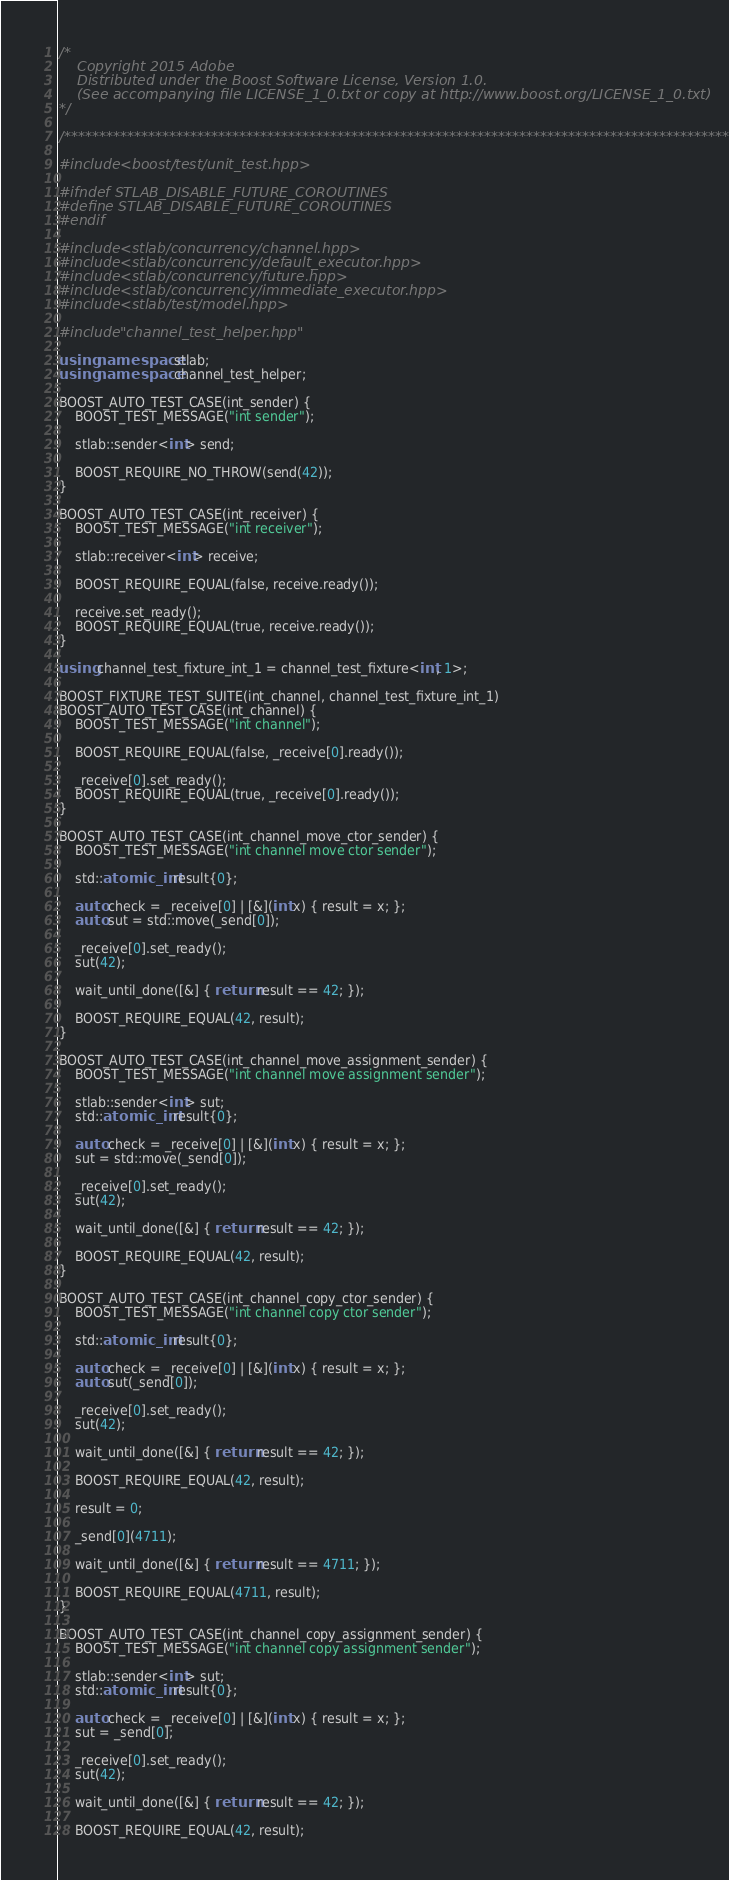<code> <loc_0><loc_0><loc_500><loc_500><_C++_>/*
    Copyright 2015 Adobe
    Distributed under the Boost Software License, Version 1.0.
    (See accompanying file LICENSE_1_0.txt or copy at http://www.boost.org/LICENSE_1_0.txt)
*/

/**************************************************************************************************/

#include <boost/test/unit_test.hpp>

#ifndef STLAB_DISABLE_FUTURE_COROUTINES
#define STLAB_DISABLE_FUTURE_COROUTINES
#endif

#include <stlab/concurrency/channel.hpp>
#include <stlab/concurrency/default_executor.hpp>
#include <stlab/concurrency/future.hpp>
#include <stlab/concurrency/immediate_executor.hpp>
#include <stlab/test/model.hpp>

#include "channel_test_helper.hpp"

using namespace stlab;
using namespace channel_test_helper;

BOOST_AUTO_TEST_CASE(int_sender) {
    BOOST_TEST_MESSAGE("int sender");

    stlab::sender<int> send;

    BOOST_REQUIRE_NO_THROW(send(42));
}

BOOST_AUTO_TEST_CASE(int_receiver) {
    BOOST_TEST_MESSAGE("int receiver");

    stlab::receiver<int> receive;

    BOOST_REQUIRE_EQUAL(false, receive.ready());

    receive.set_ready();
    BOOST_REQUIRE_EQUAL(true, receive.ready());
}

using channel_test_fixture_int_1 = channel_test_fixture<int, 1>;

BOOST_FIXTURE_TEST_SUITE(int_channel, channel_test_fixture_int_1)
BOOST_AUTO_TEST_CASE(int_channel) {
    BOOST_TEST_MESSAGE("int channel");

    BOOST_REQUIRE_EQUAL(false, _receive[0].ready());

    _receive[0].set_ready();
    BOOST_REQUIRE_EQUAL(true, _receive[0].ready());
}

BOOST_AUTO_TEST_CASE(int_channel_move_ctor_sender) {
    BOOST_TEST_MESSAGE("int channel move ctor sender");

    std::atomic_int result{0};

    auto check = _receive[0] | [&](int x) { result = x; };
    auto sut = std::move(_send[0]);

    _receive[0].set_ready();
    sut(42);

    wait_until_done([&] { return result == 42; });

    BOOST_REQUIRE_EQUAL(42, result);
}

BOOST_AUTO_TEST_CASE(int_channel_move_assignment_sender) {
    BOOST_TEST_MESSAGE("int channel move assignment sender");

    stlab::sender<int> sut;
    std::atomic_int result{0};

    auto check = _receive[0] | [&](int x) { result = x; };
    sut = std::move(_send[0]);

    _receive[0].set_ready();
    sut(42);

    wait_until_done([&] { return result == 42; });

    BOOST_REQUIRE_EQUAL(42, result);
}

BOOST_AUTO_TEST_CASE(int_channel_copy_ctor_sender) {
    BOOST_TEST_MESSAGE("int channel copy ctor sender");

    std::atomic_int result{0};

    auto check = _receive[0] | [&](int x) { result = x; };
    auto sut(_send[0]);

    _receive[0].set_ready();
    sut(42);

    wait_until_done([&] { return result == 42; });

    BOOST_REQUIRE_EQUAL(42, result);

    result = 0;

    _send[0](4711);

    wait_until_done([&] { return result == 4711; });

    BOOST_REQUIRE_EQUAL(4711, result);
}

BOOST_AUTO_TEST_CASE(int_channel_copy_assignment_sender) {
    BOOST_TEST_MESSAGE("int channel copy assignment sender");

    stlab::sender<int> sut;
    std::atomic_int result{0};

    auto check = _receive[0] | [&](int x) { result = x; };
    sut = _send[0];

    _receive[0].set_ready();
    sut(42);

    wait_until_done([&] { return result == 42; });

    BOOST_REQUIRE_EQUAL(42, result);
</code> 